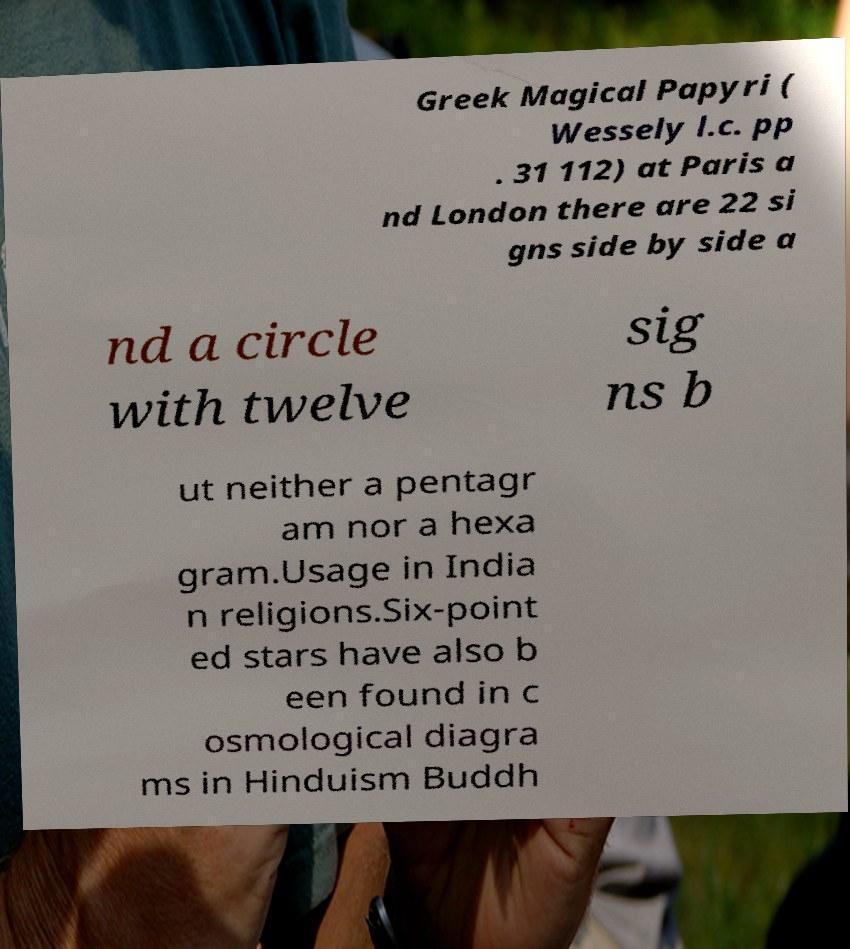Can you accurately transcribe the text from the provided image for me? Greek Magical Papyri ( Wessely l.c. pp . 31 112) at Paris a nd London there are 22 si gns side by side a nd a circle with twelve sig ns b ut neither a pentagr am nor a hexa gram.Usage in India n religions.Six-point ed stars have also b een found in c osmological diagra ms in Hinduism Buddh 